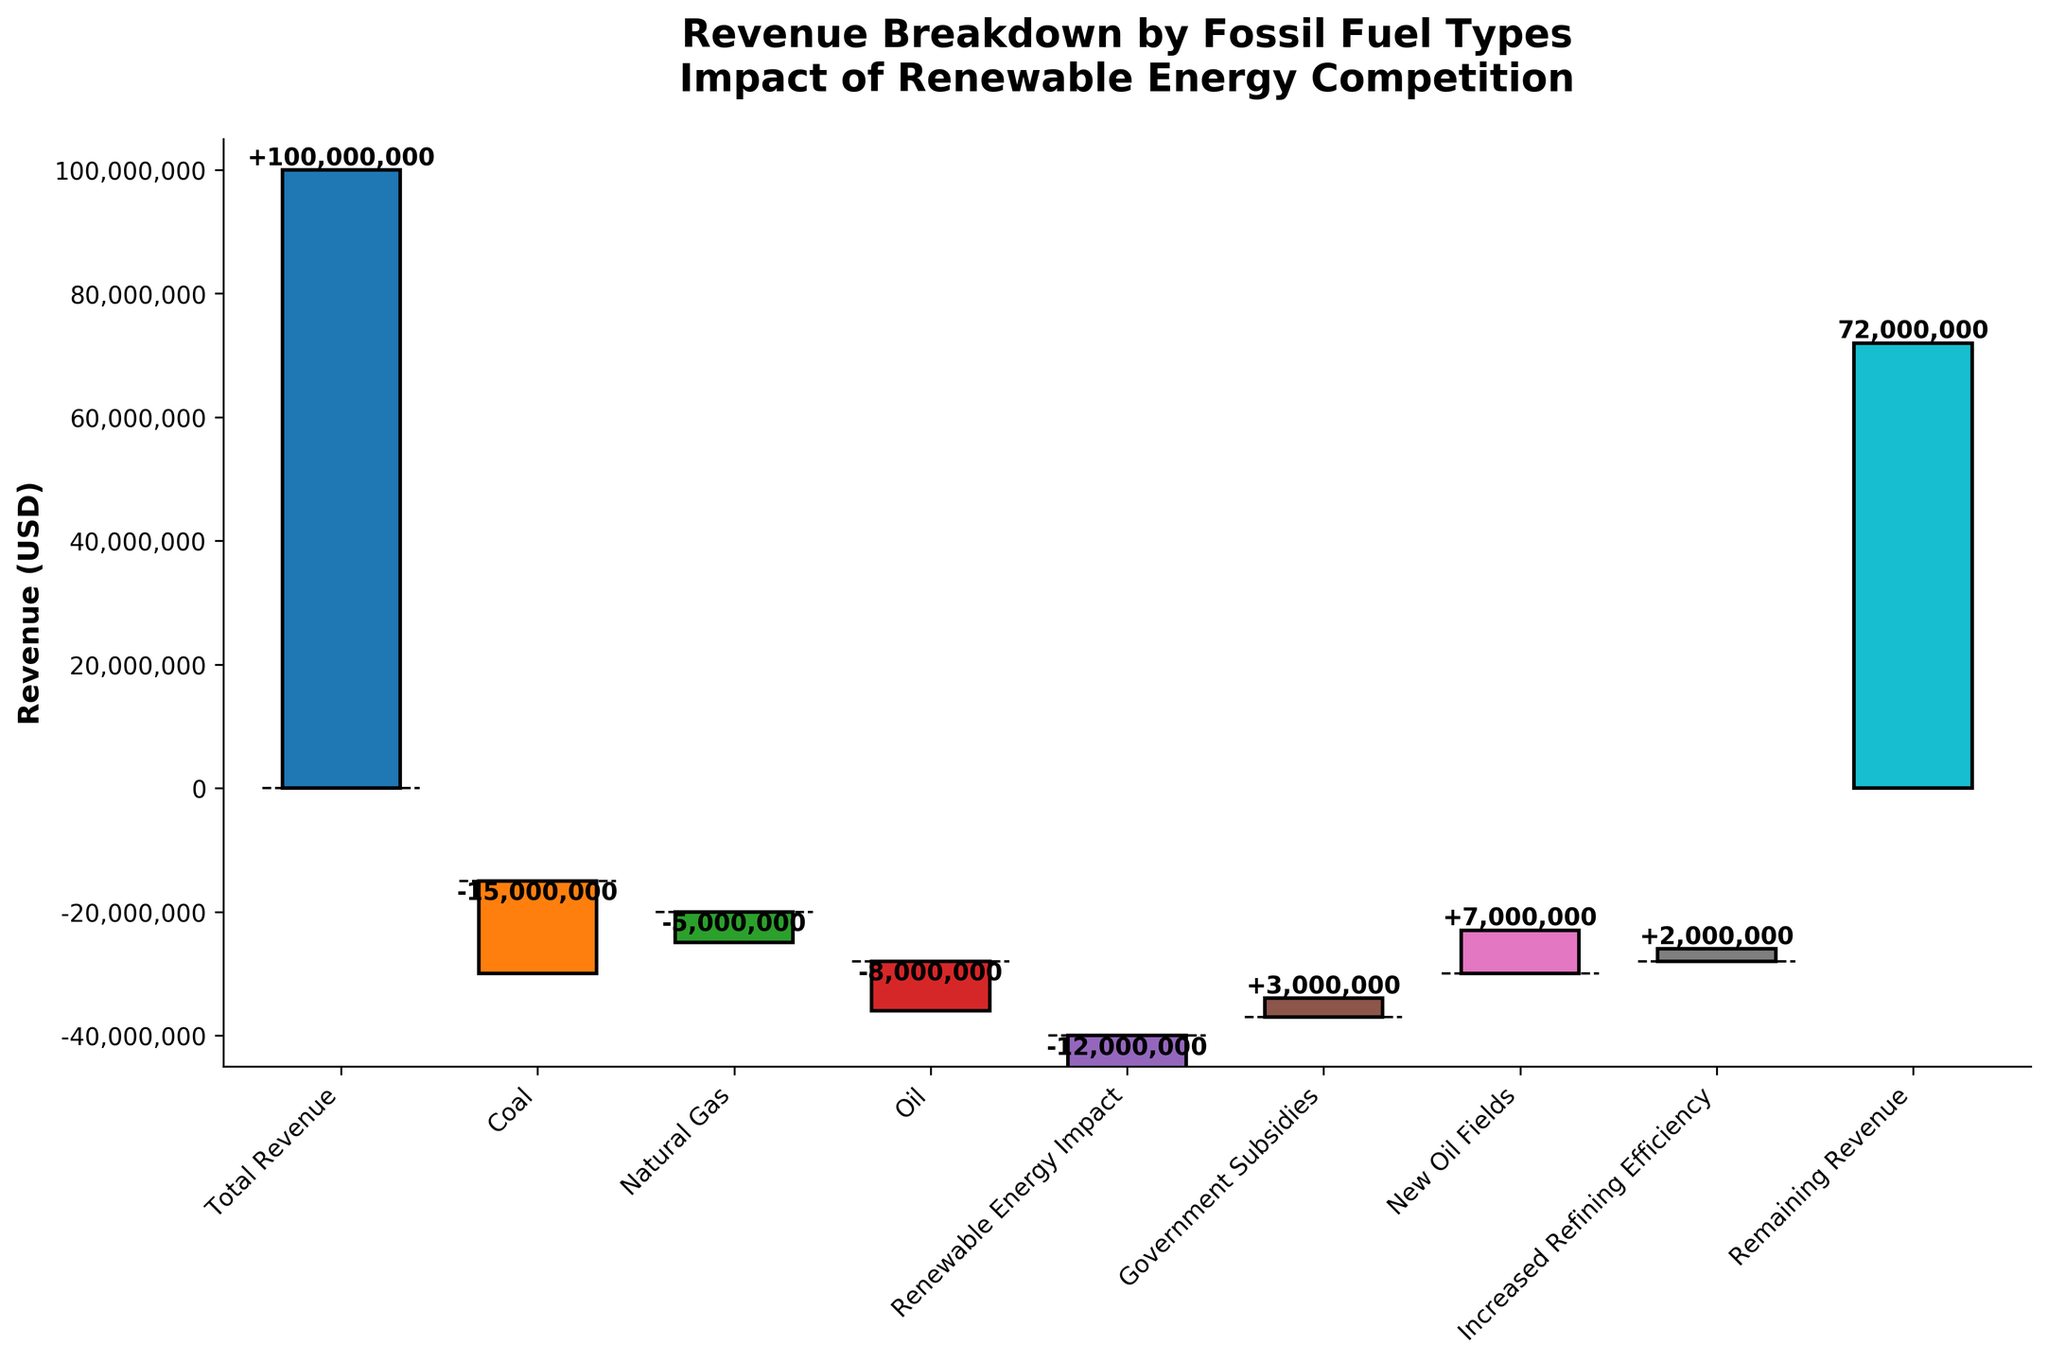What is the title of the chart? The title can be found at the top of the chart. It gives an overview of what the chart is about.
Answer: Revenue Breakdown by Fossil Fuel Types Impact of Renewable Energy Competition What is the value of 'Coal' in the chart? The value of 'Coal' can be identified from the chart by its negative bar and the label attached to it.
Answer: -15,000,000 How does 'Renewable Energy Impact' compare to 'Natural Gas'? Compare the values of 'Renewable Energy Impact' and 'Natural Gas' by looking at their respective bars. The bars show their impact on revenue with labeled values.
Answer: -12,000,000 is greater in magnitude than -5,000,000 What is the remaining revenue after accounting for all factors? The cumulative sum of all the contributing factors leads to the value labeled as 'Remaining Revenue'.
Answer: 72,000,000 Which category had the most positive impact on revenue? Looking at the bars with positive values and identifying the highest value among them.
Answer: New Oil Fields What is the cumulative impact of 'Coal', 'Natural Gas', and 'Oil' on revenue? Sum the negative values of these three categories to find the total impact on revenue.
Answer: -33,000,000 What are the two categories that decreased revenue the most? Identify the two largest negative bars in the chart.
Answer: Coal and Renewable Energy Impact If government subsidies were doubled, what would the remaining revenue be? Double the ‘Government Subsidies’ value and then recalculate the remaining revenue. The original remaining revenue is 72,000,000; adding an extra 3,000,000 would give 75,000,000.
Answer: 75,000,000 How does 'Increased Refining Efficiency' affect revenue as compared to 'Government Subsidies'? Compare the bars of these two categories by their respective values.
Answer: Increased Refining Efficiency has less impact (2,000,000) compared to Government Subsidies (3,000,000) What is the total revenue before considering any impacts? The starting value labeled 'Total Revenue' at the very beginning of the chart.
Answer: 100,000,000 